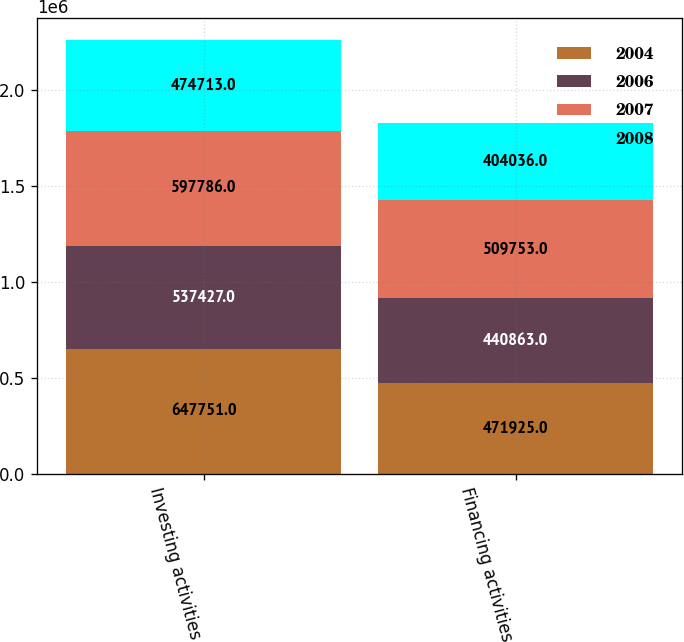<chart> <loc_0><loc_0><loc_500><loc_500><stacked_bar_chart><ecel><fcel>Investing activities<fcel>Financing activities<nl><fcel>2004<fcel>647751<fcel>471925<nl><fcel>2006<fcel>537427<fcel>440863<nl><fcel>2007<fcel>597786<fcel>509753<nl><fcel>2008<fcel>474713<fcel>404036<nl></chart> 